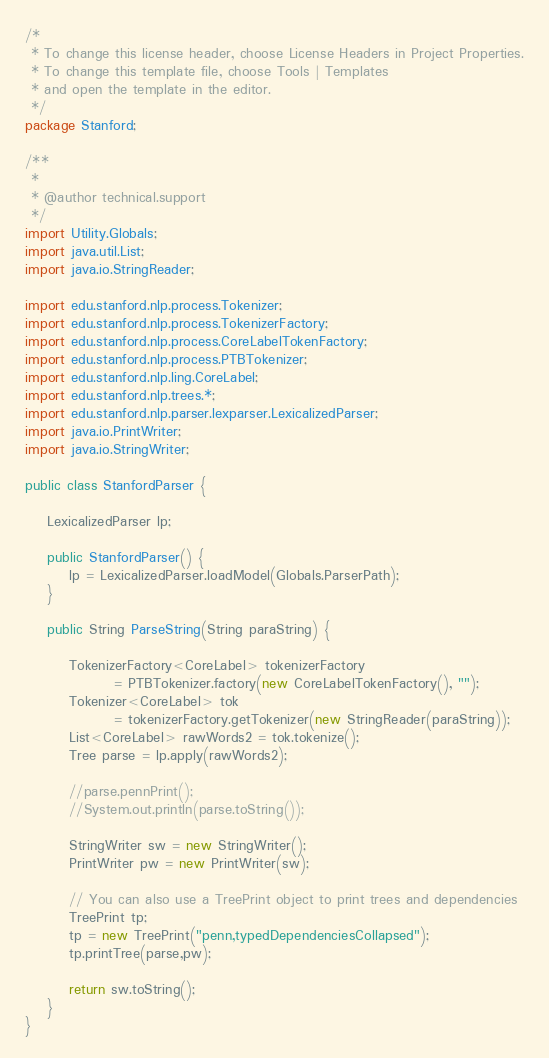<code> <loc_0><loc_0><loc_500><loc_500><_Java_>/*
 * To change this license header, choose License Headers in Project Properties.
 * To change this template file, choose Tools | Templates
 * and open the template in the editor.
 */
package Stanford;

/**
 *
 * @author technical.support
 */
import Utility.Globals;
import java.util.List;
import java.io.StringReader;

import edu.stanford.nlp.process.Tokenizer;
import edu.stanford.nlp.process.TokenizerFactory;
import edu.stanford.nlp.process.CoreLabelTokenFactory;
import edu.stanford.nlp.process.PTBTokenizer;
import edu.stanford.nlp.ling.CoreLabel;
import edu.stanford.nlp.trees.*;
import edu.stanford.nlp.parser.lexparser.LexicalizedParser;
import java.io.PrintWriter;
import java.io.StringWriter;

public class StanfordParser {

    LexicalizedParser lp;

    public StanfordParser() {        
        lp = LexicalizedParser.loadModel(Globals.ParserPath);
    }

    public String ParseString(String paraString) {

        TokenizerFactory<CoreLabel> tokenizerFactory
                = PTBTokenizer.factory(new CoreLabelTokenFactory(), "");
        Tokenizer<CoreLabel> tok
                = tokenizerFactory.getTokenizer(new StringReader(paraString));
        List<CoreLabel> rawWords2 = tok.tokenize();
        Tree parse = lp.apply(rawWords2);
        
        //parse.pennPrint();
        //System.out.println(parse.toString());

        StringWriter sw = new StringWriter();
        PrintWriter pw = new PrintWriter(sw);
    
        // You can also use a TreePrint object to print trees and dependencies
        TreePrint tp;
        tp = new TreePrint("penn,typedDependenciesCollapsed");
        tp.printTree(parse,pw);
        
        return sw.toString();
    }
}
</code> 